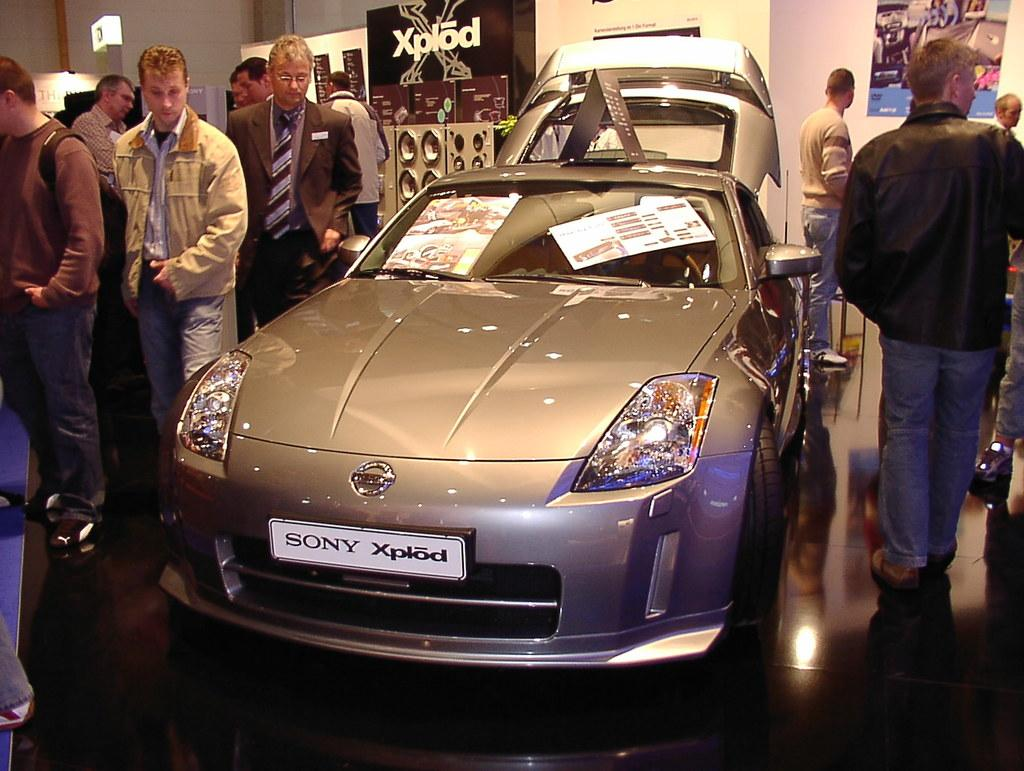What is the main subject of the image? The main subject of the image is a car. What are the people near the car doing? There are people standing near the car, but their actions are not specified in the facts. What can be seen in the background of the image? In the background of the image, there is a wall and banners. What type of mitten is being used to hold the banners in the image? There is no mitten present in the image, and the banners are not being held by any visible object or person. 